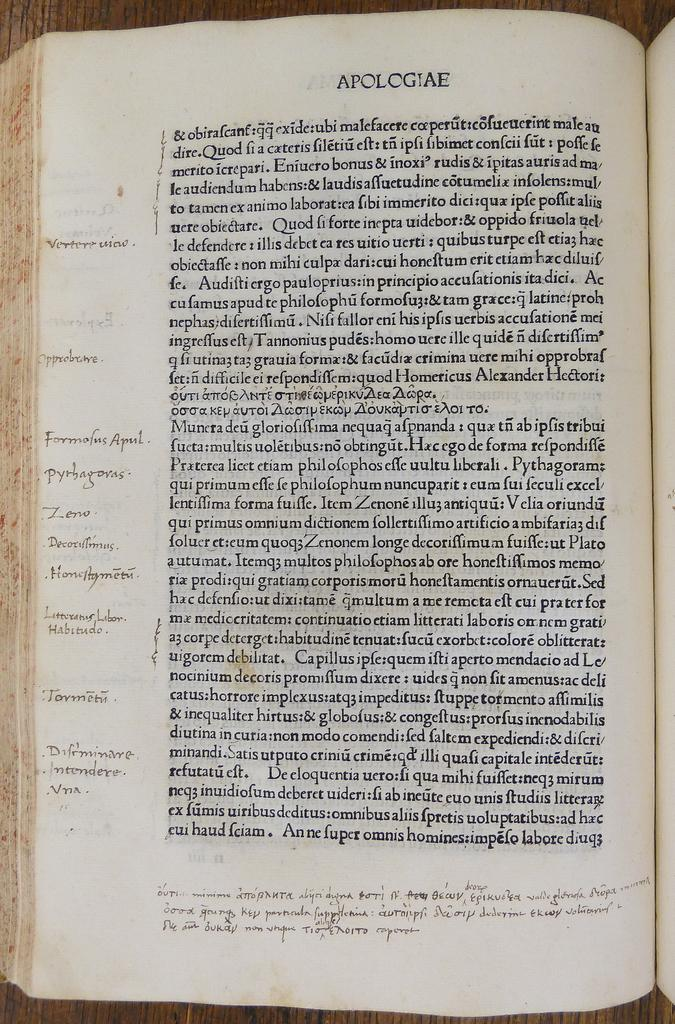<image>
Relay a brief, clear account of the picture shown. the word apologiae is on the white book 